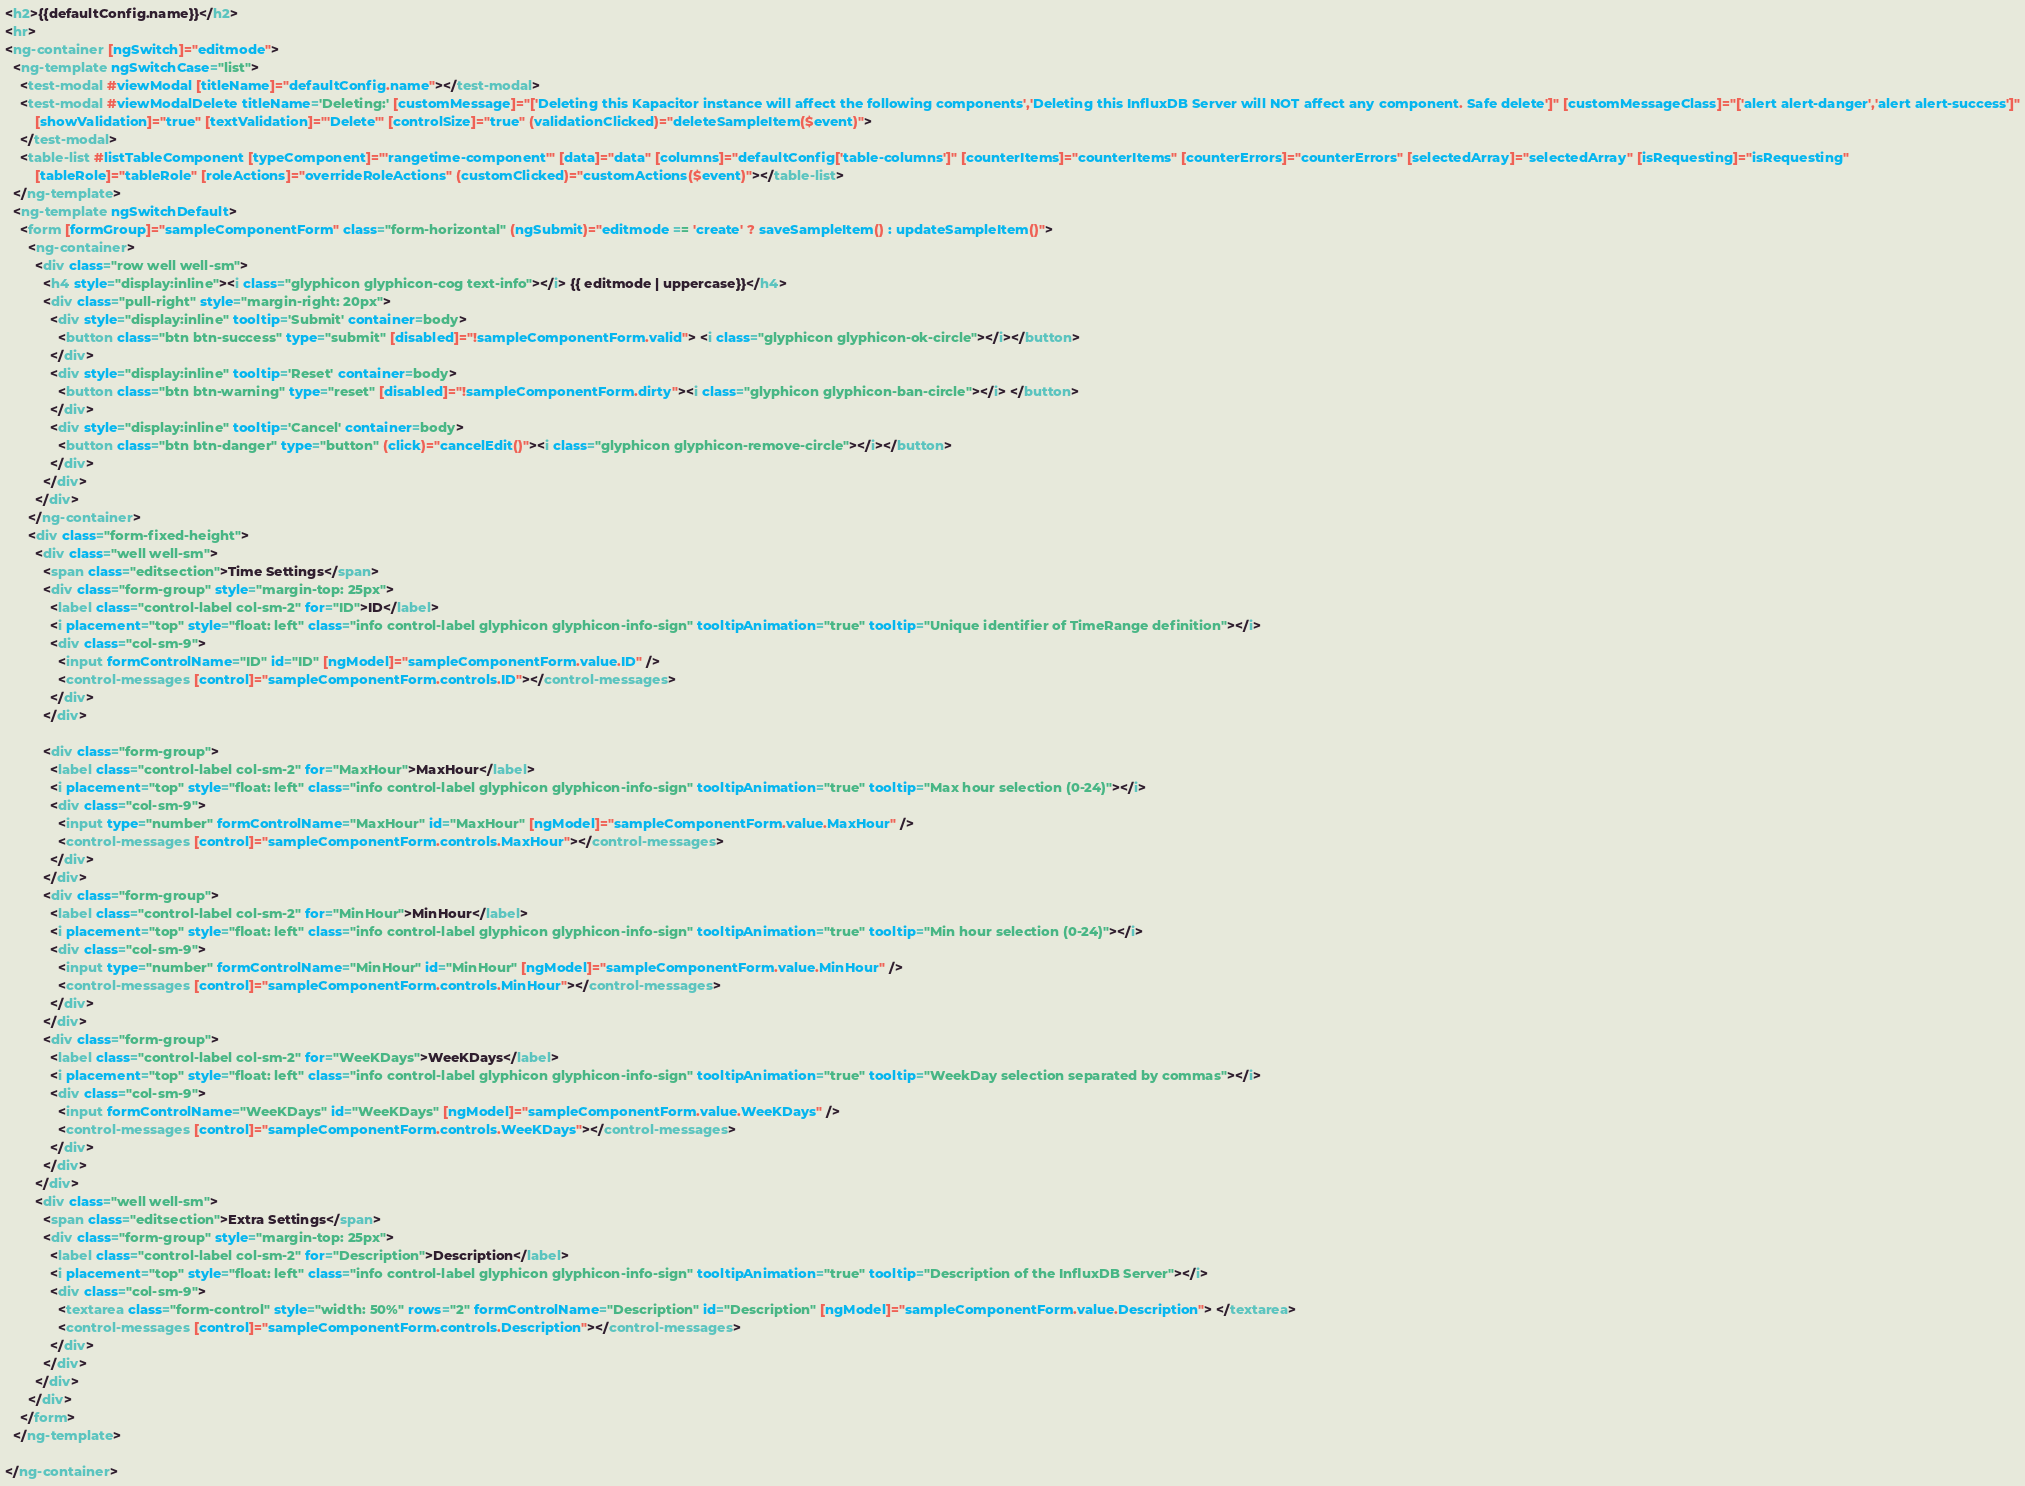Convert code to text. <code><loc_0><loc_0><loc_500><loc_500><_HTML_><h2>{{defaultConfig.name}}</h2>
<hr>
<ng-container [ngSwitch]="editmode">
  <ng-template ngSwitchCase="list">
    <test-modal #viewModal [titleName]="defaultConfig.name"></test-modal>
    <test-modal #viewModalDelete titleName='Deleting:' [customMessage]="['Deleting this Kapacitor instance will affect the following components','Deleting this InfluxDB Server will NOT affect any component. Safe delete']" [customMessageClass]="['alert alert-danger','alert alert-success']"
        [showValidation]="true" [textValidation]="'Delete'" [controlSize]="true" (validationClicked)="deleteSampleItem($event)">
    </test-modal>
    <table-list #listTableComponent [typeComponent]="'rangetime-component'" [data]="data" [columns]="defaultConfig['table-columns']" [counterItems]="counterItems" [counterErrors]="counterErrors" [selectedArray]="selectedArray" [isRequesting]="isRequesting"
        [tableRole]="tableRole" [roleActions]="overrideRoleActions" (customClicked)="customActions($event)"></table-list>
  </ng-template>
  <ng-template ngSwitchDefault>
    <form [formGroup]="sampleComponentForm" class="form-horizontal" (ngSubmit)="editmode == 'create' ? saveSampleItem() : updateSampleItem()">
      <ng-container>
        <div class="row well well-sm">
          <h4 style="display:inline"><i class="glyphicon glyphicon-cog text-info"></i> {{ editmode | uppercase}}</h4>
          <div class="pull-right" style="margin-right: 20px">
            <div style="display:inline" tooltip='Submit' container=body>
              <button class="btn btn-success" type="submit" [disabled]="!sampleComponentForm.valid"> <i class="glyphicon glyphicon-ok-circle"></i></button>
            </div>
            <div style="display:inline" tooltip='Reset' container=body>
              <button class="btn btn-warning" type="reset" [disabled]="!sampleComponentForm.dirty"><i class="glyphicon glyphicon-ban-circle"></i> </button>
            </div>
            <div style="display:inline" tooltip='Cancel' container=body>
              <button class="btn btn-danger" type="button" (click)="cancelEdit()"><i class="glyphicon glyphicon-remove-circle"></i></button>
            </div>
          </div>
        </div>
      </ng-container>
      <div class="form-fixed-height">
        <div class="well well-sm">
          <span class="editsection">Time Settings</span>
          <div class="form-group" style="margin-top: 25px">
            <label class="control-label col-sm-2" for="ID">ID</label>
            <i placement="top" style="float: left" class="info control-label glyphicon glyphicon-info-sign" tooltipAnimation="true" tooltip="Unique identifier of TimeRange definition"></i>
            <div class="col-sm-9">
              <input formControlName="ID" id="ID" [ngModel]="sampleComponentForm.value.ID" />
              <control-messages [control]="sampleComponentForm.controls.ID"></control-messages>
            </div>
          </div>

          <div class="form-group">
            <label class="control-label col-sm-2" for="MaxHour">MaxHour</label>
            <i placement="top" style="float: left" class="info control-label glyphicon glyphicon-info-sign" tooltipAnimation="true" tooltip="Max hour selection (0-24)"></i>
            <div class="col-sm-9">
              <input type="number" formControlName="MaxHour" id="MaxHour" [ngModel]="sampleComponentForm.value.MaxHour" />
              <control-messages [control]="sampleComponentForm.controls.MaxHour"></control-messages>
            </div>
          </div>
          <div class="form-group">
            <label class="control-label col-sm-2" for="MinHour">MinHour</label>
            <i placement="top" style="float: left" class="info control-label glyphicon glyphicon-info-sign" tooltipAnimation="true" tooltip="Min hour selection (0-24)"></i>
            <div class="col-sm-9">
              <input type="number" formControlName="MinHour" id="MinHour" [ngModel]="sampleComponentForm.value.MinHour" />
              <control-messages [control]="sampleComponentForm.controls.MinHour"></control-messages>
            </div>
          </div>
          <div class="form-group">
            <label class="control-label col-sm-2" for="WeeKDays">WeeKDays</label>
            <i placement="top" style="float: left" class="info control-label glyphicon glyphicon-info-sign" tooltipAnimation="true" tooltip="WeekDay selection separated by commas"></i>
            <div class="col-sm-9">
              <input formControlName="WeeKDays" id="WeeKDays" [ngModel]="sampleComponentForm.value.WeeKDays" />
              <control-messages [control]="sampleComponentForm.controls.WeeKDays"></control-messages>
            </div>
          </div>
        </div>
        <div class="well well-sm">
          <span class="editsection">Extra Settings</span>
          <div class="form-group" style="margin-top: 25px">
            <label class="control-label col-sm-2" for="Description">Description</label>
            <i placement="top" style="float: left" class="info control-label glyphicon glyphicon-info-sign" tooltipAnimation="true" tooltip="Description of the InfluxDB Server"></i>
            <div class="col-sm-9">
              <textarea class="form-control" style="width: 50%" rows="2" formControlName="Description" id="Description" [ngModel]="sampleComponentForm.value.Description"> </textarea>
              <control-messages [control]="sampleComponentForm.controls.Description"></control-messages>
            </div>
          </div>
        </div>
      </div>
    </form>
  </ng-template>

</ng-container>
</code> 